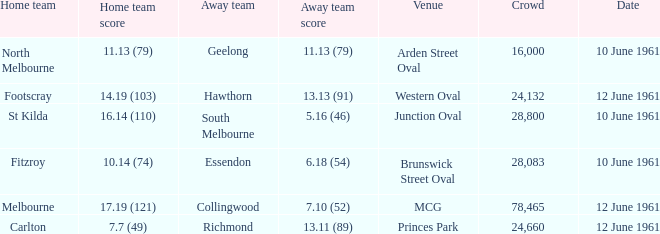Which venue has a crowd over 16,000 and a home team score of 7.7 (49)? Princes Park. 